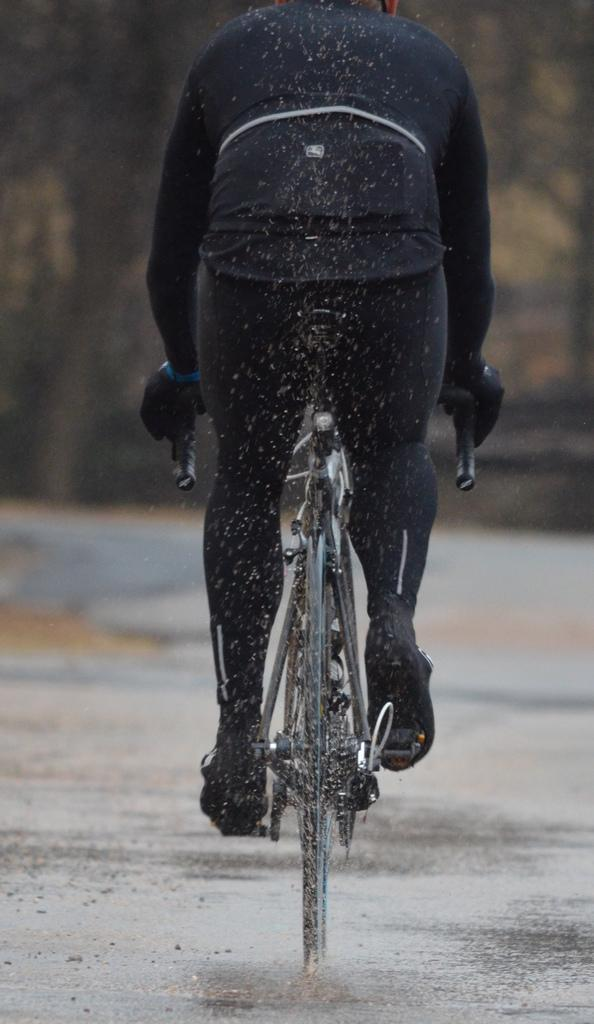Who is the main subject in the image? There is a person in the image. What is the person doing in the image? The person is riding a bicycle. Where is the bicycle located? The bicycle is on the road. Can you describe the background of the image? The background of the image is blurred. What type of impulse can be seen affecting the person's skirt in the image? There is no skirt present in the image, and therefore no impulse affecting it. 